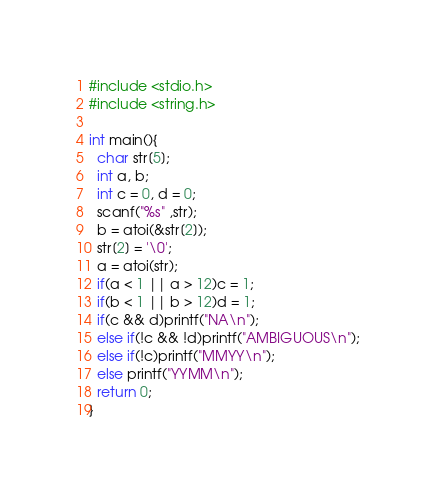<code> <loc_0><loc_0><loc_500><loc_500><_C_>#include <stdio.h>
#include <string.h>

int main(){
  char str[5];
  int a, b;
  int c = 0, d = 0;
  scanf("%s" ,str);
  b = atoi(&str[2]);
  str[2] = '\0';
  a = atoi(str);
  if(a < 1 || a > 12)c = 1;
  if(b < 1 || b > 12)d = 1;
  if(c && d)printf("NA\n");
  else if(!c && !d)printf("AMBIGUOUS\n");
  else if(!c)printf("MMYY\n");
  else printf("YYMM\n");
  return 0;
}</code> 